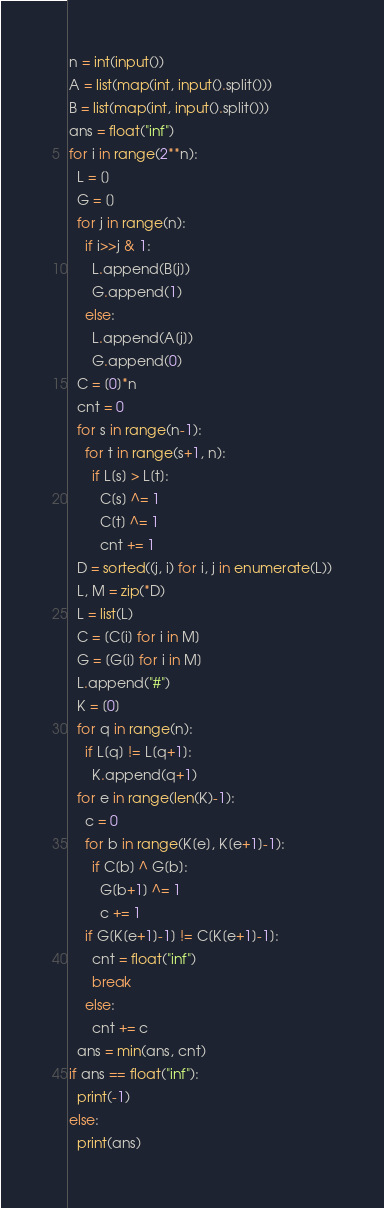Convert code to text. <code><loc_0><loc_0><loc_500><loc_500><_Python_>n = int(input())
A = list(map(int, input().split()))
B = list(map(int, input().split()))
ans = float("inf")
for i in range(2**n):
  L = []
  G = []
  for j in range(n):
    if i>>j & 1:
      L.append(B[j])
      G.append(1)
    else:
      L.append(A[j])
      G.append(0)
  C = [0]*n
  cnt = 0
  for s in range(n-1):
    for t in range(s+1, n):
      if L[s] > L[t]:
        C[s] ^= 1
        C[t] ^= 1
        cnt += 1
  D = sorted((j, i) for i, j in enumerate(L))
  L, M = zip(*D)
  L = list(L)
  C = [C[i] for i in M]
  G = [G[i] for i in M]
  L.append("#")
  K = [0]
  for q in range(n):
    if L[q] != L[q+1]:
      K.append(q+1)
  for e in range(len(K)-1):
    c = 0
    for b in range(K[e], K[e+1]-1):
      if C[b] ^ G[b]:
        G[b+1] ^= 1
        c += 1
    if G[K[e+1]-1] != C[K[e+1]-1]:
      cnt = float("inf")
      break
    else:
      cnt += c
  ans = min(ans, cnt)
if ans == float("inf"):
  print(-1)
else:
  print(ans)</code> 